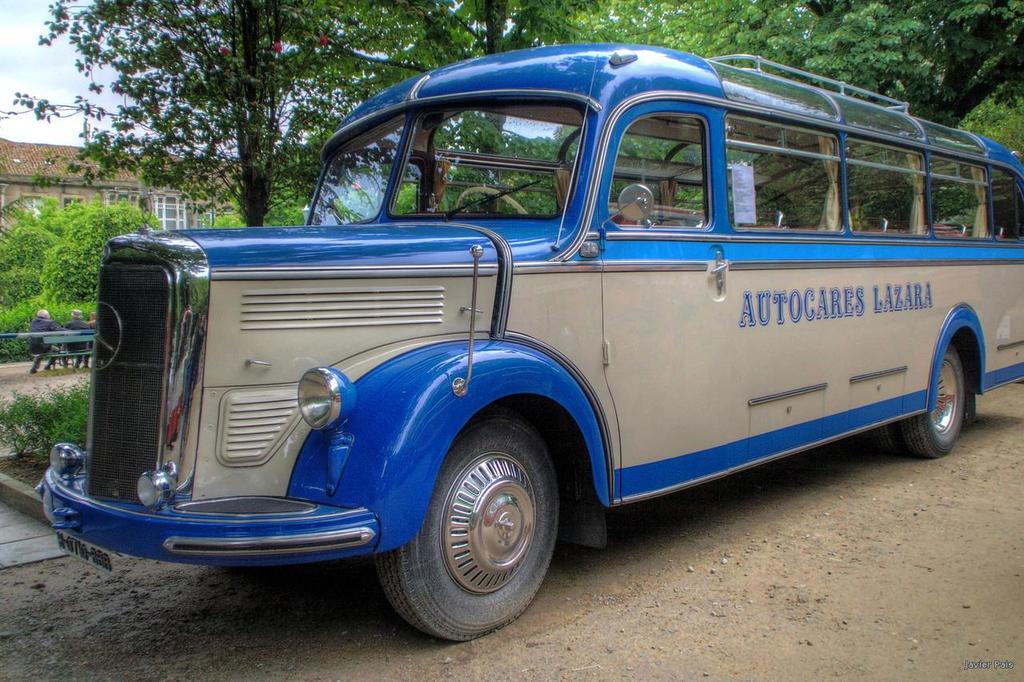What is the main subject of the image? There is a bus on the road in the image. What can be seen in the background of the image? There are trees, buildings, and people sitting on a bench in the background of the image. Can you tell me how many goldfish are swimming in the bus in the image? There are no goldfish present in the image, as it features a bus on the road with a background of trees, buildings, and people sitting on a bench. 